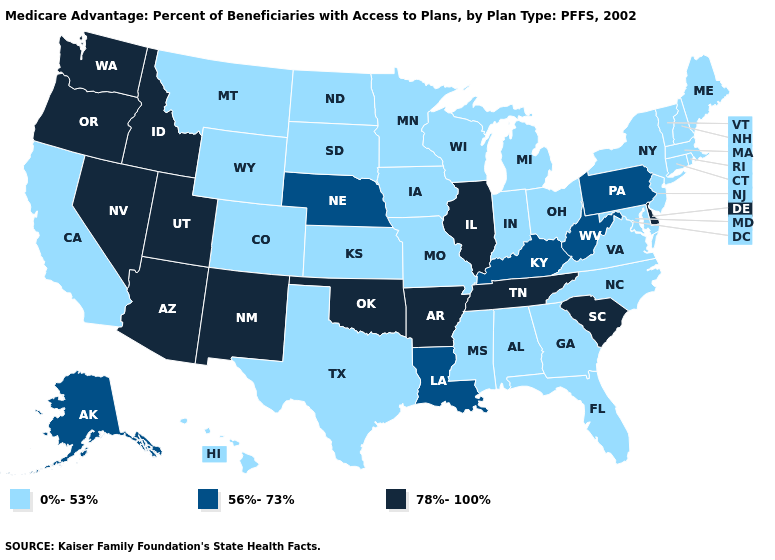Does Vermont have the lowest value in the USA?
Answer briefly. Yes. What is the value of Mississippi?
Answer briefly. 0%-53%. Among the states that border New York , which have the highest value?
Be succinct. Pennsylvania. Which states hav the highest value in the South?
Give a very brief answer. Arkansas, Delaware, Oklahoma, South Carolina, Tennessee. How many symbols are there in the legend?
Give a very brief answer. 3. What is the highest value in the USA?
Be succinct. 78%-100%. What is the value of New Mexico?
Answer briefly. 78%-100%. What is the lowest value in the Northeast?
Be succinct. 0%-53%. What is the lowest value in states that border Kentucky?
Concise answer only. 0%-53%. Among the states that border Missouri , which have the lowest value?
Concise answer only. Iowa, Kansas. Name the states that have a value in the range 0%-53%?
Give a very brief answer. Alabama, California, Colorado, Connecticut, Florida, Georgia, Hawaii, Iowa, Indiana, Kansas, Massachusetts, Maryland, Maine, Michigan, Minnesota, Missouri, Mississippi, Montana, North Carolina, North Dakota, New Hampshire, New Jersey, New York, Ohio, Rhode Island, South Dakota, Texas, Virginia, Vermont, Wisconsin, Wyoming. What is the value of Vermont?
Keep it brief. 0%-53%. What is the highest value in states that border Virginia?
Answer briefly. 78%-100%. Name the states that have a value in the range 78%-100%?
Concise answer only. Arkansas, Arizona, Delaware, Idaho, Illinois, New Mexico, Nevada, Oklahoma, Oregon, South Carolina, Tennessee, Utah, Washington. Is the legend a continuous bar?
Write a very short answer. No. 